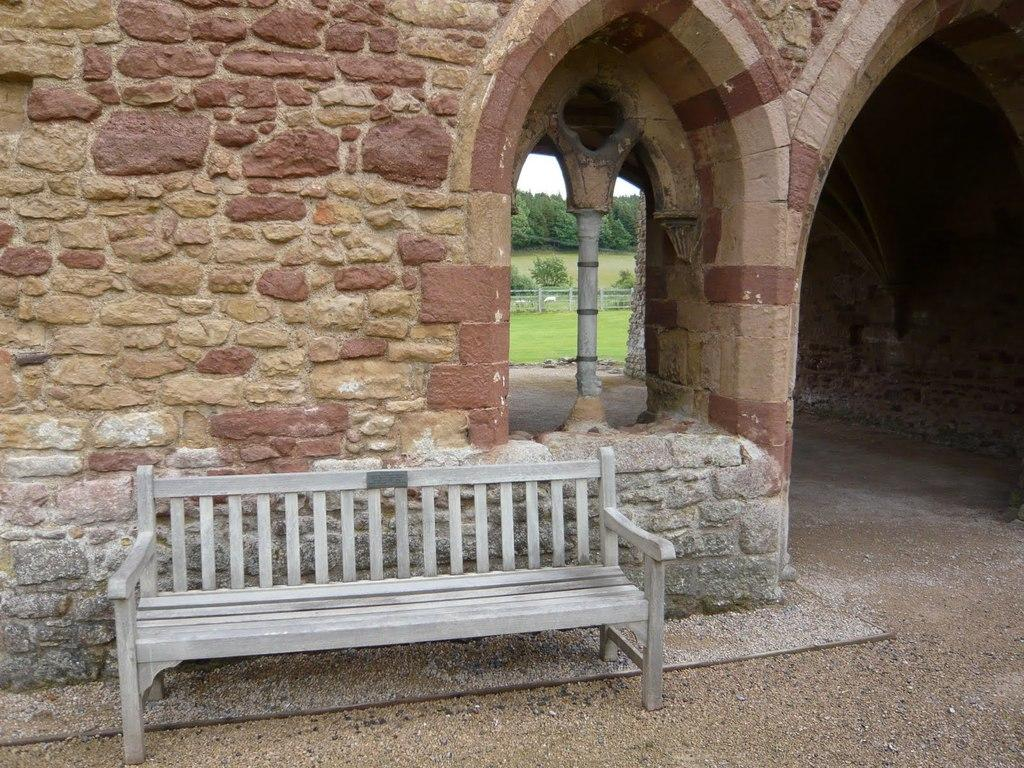What is located in the center of the image? There is a bench in the center of the image. What can be seen in the background of the image? There is an arch and a wall in the background of the image. What type of vegetation is visible in the background of the image? Trees are present in the background of the image. What architectural feature is present in the image? There is a fence in the image. How does the wrist affect the growth of the trees in the image? There is no wrist present in the image, and therefore it cannot affect the growth of the trees. 